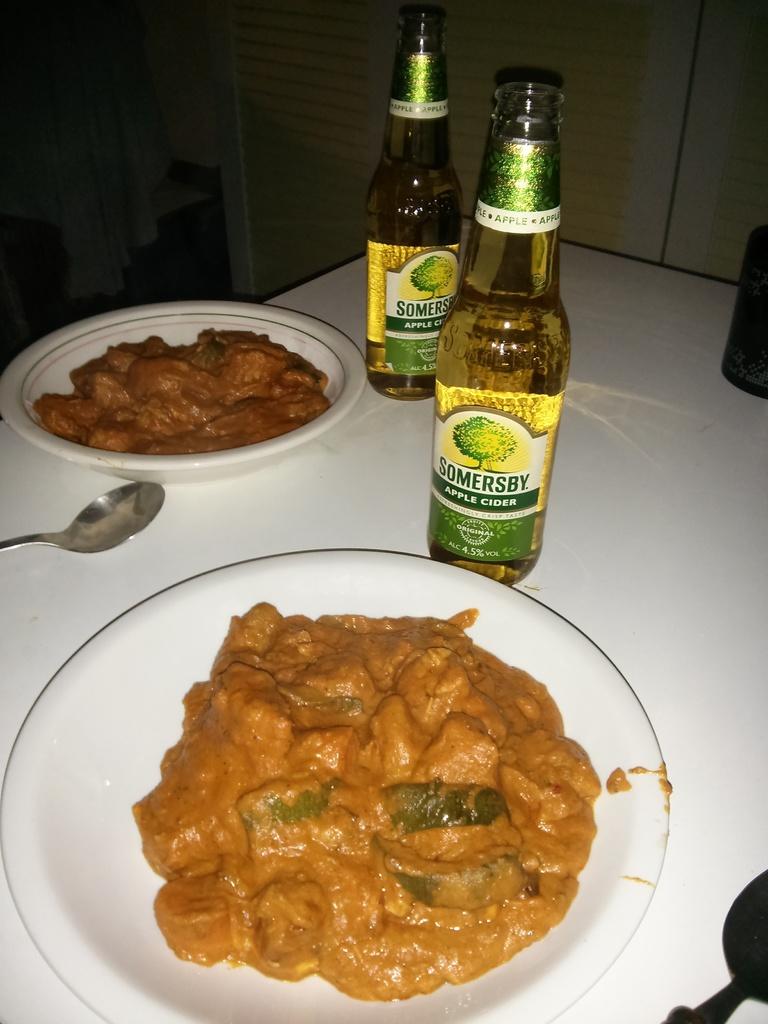What brand is the beer next to the plate?
Your answer should be very brief. Somersby. What type of cider is in the bottle?
Keep it short and to the point. Apple. 